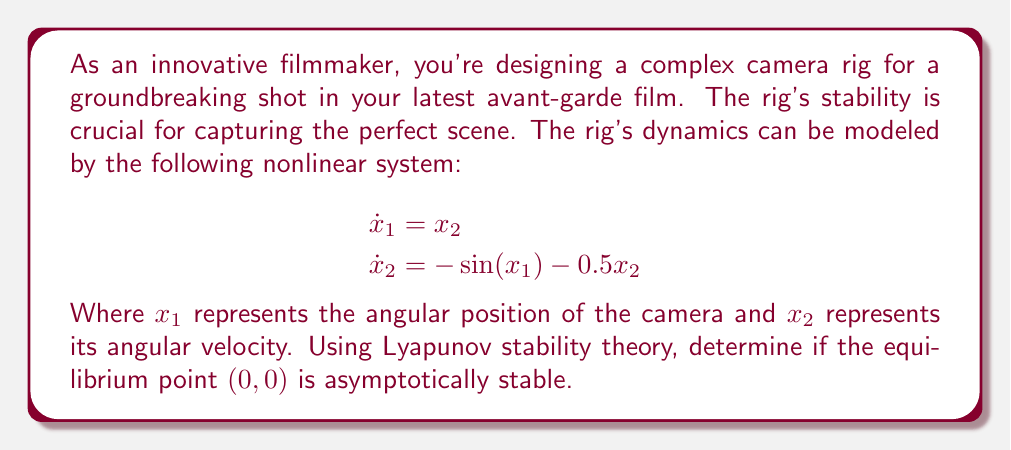Help me with this question. To analyze the stability of the equilibrium point $(0,0)$ using Lyapunov stability theory, we need to construct a Lyapunov function candidate and show that it satisfies the conditions for asymptotic stability. Let's approach this step-by-step:

1) First, let's propose a Lyapunov function candidate:

   $$V(x_1, x_2) = 1 - \cos(x_1) + \frac{1}{2}x_2^2$$

2) We need to verify that $V(x_1, x_2)$ is positive definite:
   - At the equilibrium point $(0,0)$, $V(0,0) = 1 - \cos(0) + \frac{1}{2}(0)^2 = 0$
   - For any other point, $V(x_1, x_2) > 0$ because $1 - \cos(x_1) \geq 0$ for all $x_1$, and $\frac{1}{2}x_2^2 > 0$ for all $x_2 \neq 0$

3) Now, let's calculate the time derivative of $V$:

   $$\begin{aligned}
   \dot{V} &= \frac{\partial V}{\partial x_1}\dot{x}_1 + \frac{\partial V}{\partial x_2}\dot{x}_2 \\
   &= \sin(x_1)x_2 + x_2(-\sin(x_1) - 0.5x_2) \\
   &= -0.5x_2^2
   \end{aligned}$$

4) We can see that $\dot{V}$ is negative semi-definite (it's always non-positive for all $x_1$ and $x_2$, and zero when $x_2 = 0$).

5) To prove asymptotic stability, we need to use LaSalle's Invariance Principle. We need to show that the largest invariant set where $\dot{V} = 0$ is only the equilibrium point $(0,0)$.

6) $\dot{V} = 0$ when $x_2 = 0$. In this case:
   $$\begin{aligned}
   \dot{x}_1 &= 0 \\
   \dot{x}_2 &= -\sin(x_1)
   \end{aligned}$$

7) For this to be an invariant set (other than the equilibrium point), we need $\dot{x}_2 = 0$, which occurs only when $x_1 = 0$.

Therefore, the largest invariant set where $\dot{V} = 0$ is indeed only the equilibrium point $(0,0)$.

By LaSalle's Invariance Principle, we can conclude that the equilibrium point $(0,0)$ is asymptotically stable.
Answer: The equilibrium point $(0,0)$ of the camera rig system is asymptotically stable. 